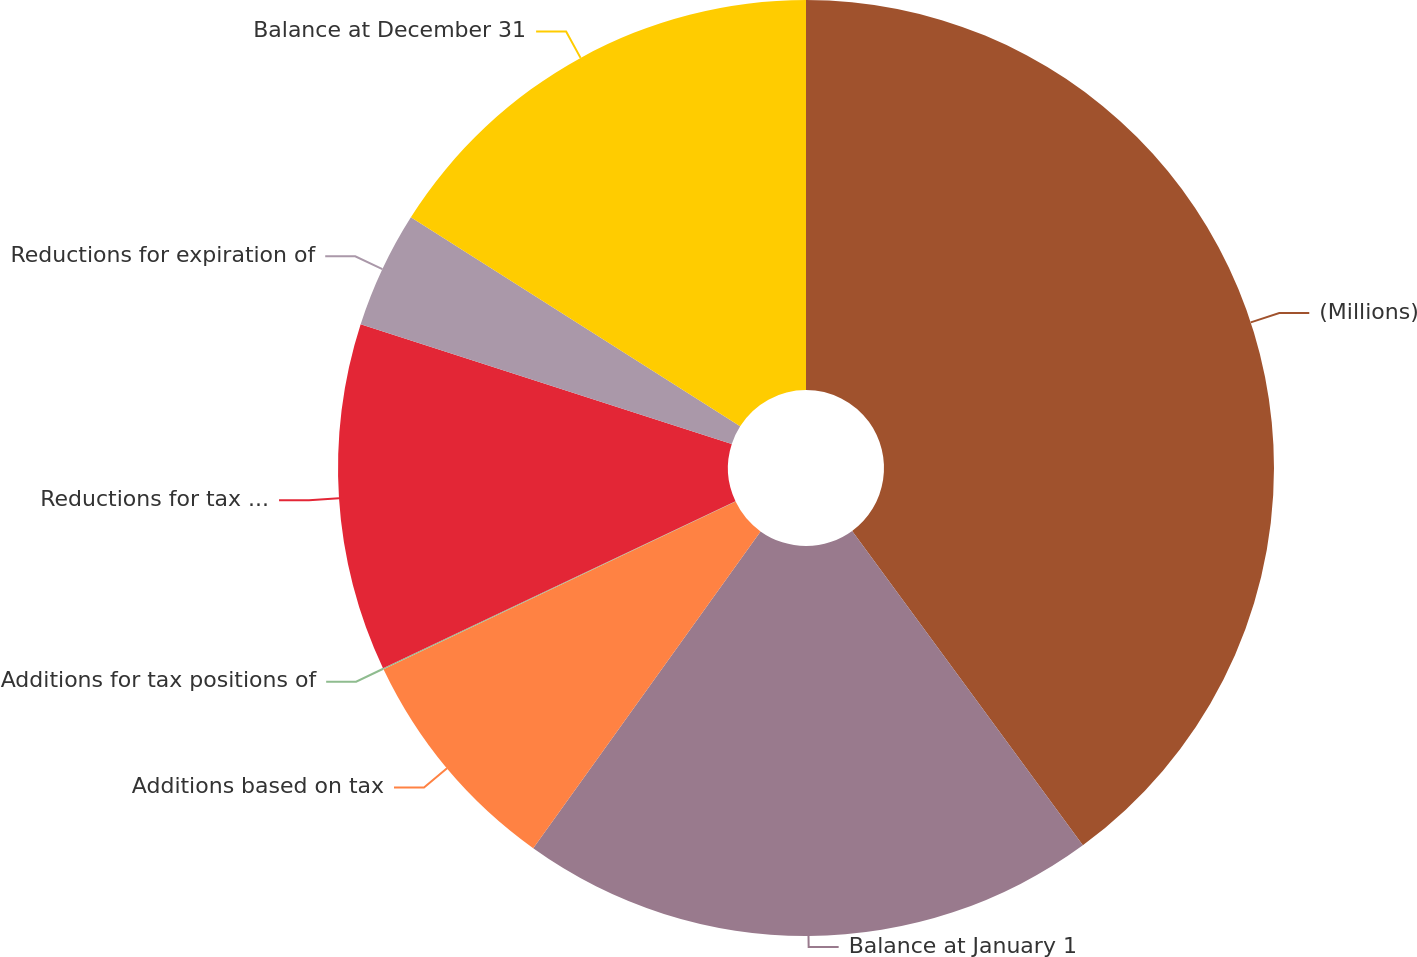<chart> <loc_0><loc_0><loc_500><loc_500><pie_chart><fcel>(Millions)<fcel>Balance at January 1<fcel>Additions based on tax<fcel>Additions for tax positions of<fcel>Reductions for tax positions<fcel>Reductions for expiration of<fcel>Balance at December 31<nl><fcel>39.93%<fcel>19.98%<fcel>8.02%<fcel>0.04%<fcel>12.01%<fcel>4.03%<fcel>16.0%<nl></chart> 